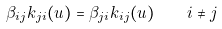Convert formula to latex. <formula><loc_0><loc_0><loc_500><loc_500>\beta _ { i j } k _ { j i } ( u ) = \beta _ { j i } k _ { i j } ( u ) \quad i \neq j</formula> 